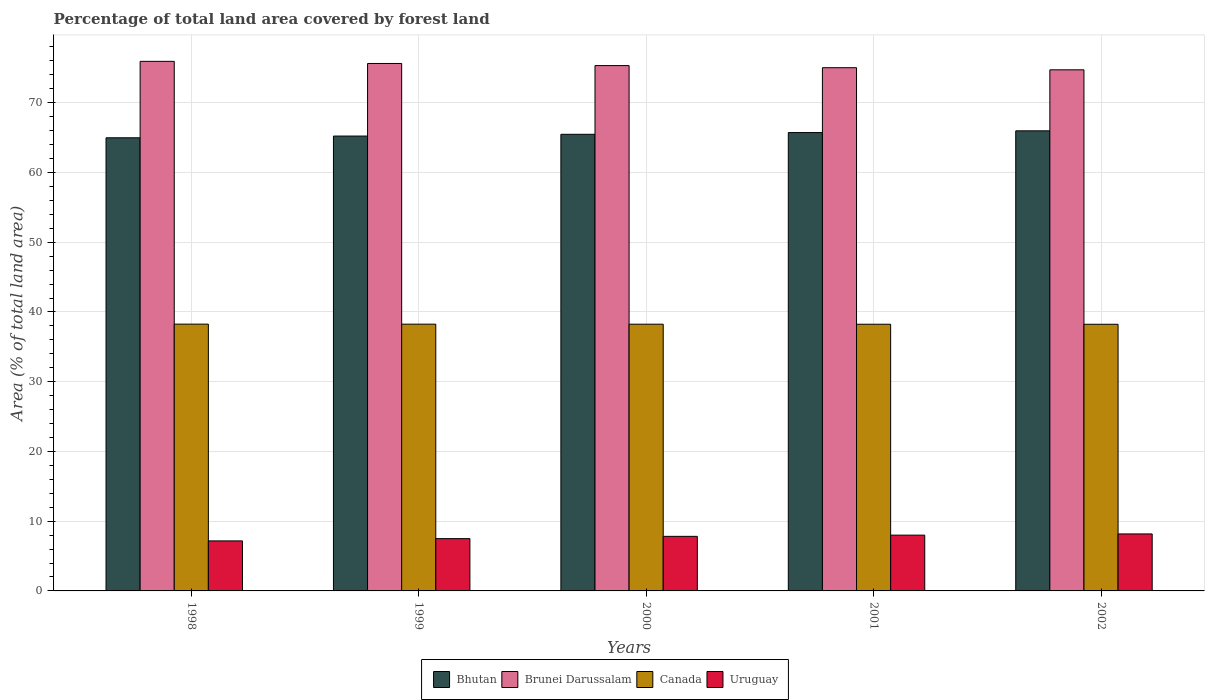How many different coloured bars are there?
Your answer should be compact. 4. How many groups of bars are there?
Offer a terse response. 5. Are the number of bars on each tick of the X-axis equal?
Ensure brevity in your answer.  Yes. How many bars are there on the 2nd tick from the left?
Your answer should be very brief. 4. How many bars are there on the 4th tick from the right?
Provide a succinct answer. 4. In how many cases, is the number of bars for a given year not equal to the number of legend labels?
Keep it short and to the point. 0. What is the percentage of forest land in Uruguay in 1999?
Provide a succinct answer. 7.5. Across all years, what is the maximum percentage of forest land in Bhutan?
Give a very brief answer. 65.98. Across all years, what is the minimum percentage of forest land in Canada?
Provide a short and direct response. 38.24. In which year was the percentage of forest land in Bhutan maximum?
Your answer should be compact. 2002. In which year was the percentage of forest land in Bhutan minimum?
Your response must be concise. 1998. What is the total percentage of forest land in Brunei Darussalam in the graph?
Provide a succinct answer. 376.66. What is the difference between the percentage of forest land in Brunei Darussalam in 1999 and that in 2002?
Keep it short and to the point. 0.91. What is the difference between the percentage of forest land in Bhutan in 2001 and the percentage of forest land in Brunei Darussalam in 1999?
Give a very brief answer. -9.91. What is the average percentage of forest land in Bhutan per year?
Offer a very short reply. 65.48. In the year 2001, what is the difference between the percentage of forest land in Bhutan and percentage of forest land in Canada?
Offer a very short reply. 27.48. In how many years, is the percentage of forest land in Bhutan greater than 50 %?
Provide a short and direct response. 5. What is the ratio of the percentage of forest land in Uruguay in 1998 to that in 2002?
Give a very brief answer. 0.88. What is the difference between the highest and the second highest percentage of forest land in Bhutan?
Your answer should be compact. 0.25. What is the difference between the highest and the lowest percentage of forest land in Brunei Darussalam?
Give a very brief answer. 1.21. Is it the case that in every year, the sum of the percentage of forest land in Canada and percentage of forest land in Uruguay is greater than the sum of percentage of forest land in Brunei Darussalam and percentage of forest land in Bhutan?
Keep it short and to the point. No. What does the 4th bar from the right in 1999 represents?
Make the answer very short. Bhutan. Is it the case that in every year, the sum of the percentage of forest land in Bhutan and percentage of forest land in Canada is greater than the percentage of forest land in Uruguay?
Your answer should be compact. Yes. Are all the bars in the graph horizontal?
Give a very brief answer. No. What is the difference between two consecutive major ticks on the Y-axis?
Keep it short and to the point. 10. Does the graph contain grids?
Your response must be concise. Yes. What is the title of the graph?
Offer a very short reply. Percentage of total land area covered by forest land. Does "Norway" appear as one of the legend labels in the graph?
Your response must be concise. No. What is the label or title of the Y-axis?
Your response must be concise. Area (% of total land area). What is the Area (% of total land area) of Bhutan in 1998?
Your answer should be compact. 64.98. What is the Area (% of total land area) of Brunei Darussalam in 1998?
Your response must be concise. 75.94. What is the Area (% of total land area) in Canada in 1998?
Offer a terse response. 38.26. What is the Area (% of total land area) in Uruguay in 1998?
Your answer should be very brief. 7.17. What is the Area (% of total land area) in Bhutan in 1999?
Offer a very short reply. 65.23. What is the Area (% of total land area) of Brunei Darussalam in 1999?
Make the answer very short. 75.64. What is the Area (% of total land area) of Canada in 1999?
Your answer should be compact. 38.25. What is the Area (% of total land area) in Uruguay in 1999?
Your answer should be compact. 7.5. What is the Area (% of total land area) of Bhutan in 2000?
Keep it short and to the point. 65.48. What is the Area (% of total land area) of Brunei Darussalam in 2000?
Keep it short and to the point. 75.33. What is the Area (% of total land area) of Canada in 2000?
Offer a very short reply. 38.25. What is the Area (% of total land area) in Uruguay in 2000?
Keep it short and to the point. 7.83. What is the Area (% of total land area) in Bhutan in 2001?
Your answer should be very brief. 65.73. What is the Area (% of total land area) in Brunei Darussalam in 2001?
Your answer should be compact. 75.03. What is the Area (% of total land area) of Canada in 2001?
Give a very brief answer. 38.24. What is the Area (% of total land area) in Uruguay in 2001?
Give a very brief answer. 8. What is the Area (% of total land area) in Bhutan in 2002?
Offer a very short reply. 65.98. What is the Area (% of total land area) of Brunei Darussalam in 2002?
Offer a very short reply. 74.72. What is the Area (% of total land area) in Canada in 2002?
Offer a very short reply. 38.24. What is the Area (% of total land area) of Uruguay in 2002?
Make the answer very short. 8.17. Across all years, what is the maximum Area (% of total land area) in Bhutan?
Your answer should be very brief. 65.98. Across all years, what is the maximum Area (% of total land area) of Brunei Darussalam?
Offer a very short reply. 75.94. Across all years, what is the maximum Area (% of total land area) of Canada?
Provide a succinct answer. 38.26. Across all years, what is the maximum Area (% of total land area) of Uruguay?
Keep it short and to the point. 8.17. Across all years, what is the minimum Area (% of total land area) of Bhutan?
Your answer should be compact. 64.98. Across all years, what is the minimum Area (% of total land area) in Brunei Darussalam?
Your answer should be compact. 74.72. Across all years, what is the minimum Area (% of total land area) of Canada?
Provide a succinct answer. 38.24. Across all years, what is the minimum Area (% of total land area) in Uruguay?
Your answer should be compact. 7.17. What is the total Area (% of total land area) of Bhutan in the graph?
Make the answer very short. 327.39. What is the total Area (% of total land area) of Brunei Darussalam in the graph?
Your answer should be very brief. 376.66. What is the total Area (% of total land area) in Canada in the graph?
Ensure brevity in your answer.  191.24. What is the total Area (% of total land area) of Uruguay in the graph?
Provide a succinct answer. 38.67. What is the difference between the Area (% of total land area) of Bhutan in 1998 and that in 1999?
Offer a very short reply. -0.25. What is the difference between the Area (% of total land area) of Brunei Darussalam in 1998 and that in 1999?
Provide a short and direct response. 0.3. What is the difference between the Area (% of total land area) in Canada in 1998 and that in 1999?
Provide a short and direct response. 0.01. What is the difference between the Area (% of total land area) in Uruguay in 1998 and that in 1999?
Provide a short and direct response. -0.33. What is the difference between the Area (% of total land area) in Bhutan in 1998 and that in 2000?
Offer a terse response. -0.5. What is the difference between the Area (% of total land area) in Brunei Darussalam in 1998 and that in 2000?
Provide a short and direct response. 0.61. What is the difference between the Area (% of total land area) in Canada in 1998 and that in 2000?
Your answer should be compact. 0.01. What is the difference between the Area (% of total land area) in Uruguay in 1998 and that in 2000?
Provide a succinct answer. -0.65. What is the difference between the Area (% of total land area) in Bhutan in 1998 and that in 2001?
Make the answer very short. -0.75. What is the difference between the Area (% of total land area) of Brunei Darussalam in 1998 and that in 2001?
Your answer should be compact. 0.91. What is the difference between the Area (% of total land area) of Canada in 1998 and that in 2001?
Offer a very short reply. 0.02. What is the difference between the Area (% of total land area) of Uruguay in 1998 and that in 2001?
Give a very brief answer. -0.83. What is the difference between the Area (% of total land area) in Bhutan in 1998 and that in 2002?
Your answer should be compact. -1. What is the difference between the Area (% of total land area) in Brunei Darussalam in 1998 and that in 2002?
Your answer should be very brief. 1.21. What is the difference between the Area (% of total land area) in Canada in 1998 and that in 2002?
Ensure brevity in your answer.  0.02. What is the difference between the Area (% of total land area) of Uruguay in 1998 and that in 2002?
Offer a terse response. -1. What is the difference between the Area (% of total land area) of Bhutan in 1999 and that in 2000?
Keep it short and to the point. -0.25. What is the difference between the Area (% of total land area) of Brunei Darussalam in 1999 and that in 2000?
Give a very brief answer. 0.3. What is the difference between the Area (% of total land area) of Canada in 1999 and that in 2000?
Your answer should be very brief. 0.01. What is the difference between the Area (% of total land area) of Uruguay in 1999 and that in 2000?
Provide a short and direct response. -0.33. What is the difference between the Area (% of total land area) in Bhutan in 1999 and that in 2001?
Offer a terse response. -0.5. What is the difference between the Area (% of total land area) of Brunei Darussalam in 1999 and that in 2001?
Provide a short and direct response. 0.61. What is the difference between the Area (% of total land area) in Canada in 1999 and that in 2001?
Provide a succinct answer. 0.01. What is the difference between the Area (% of total land area) in Uruguay in 1999 and that in 2001?
Keep it short and to the point. -0.5. What is the difference between the Area (% of total land area) in Bhutan in 1999 and that in 2002?
Your answer should be compact. -0.75. What is the difference between the Area (% of total land area) of Brunei Darussalam in 1999 and that in 2002?
Keep it short and to the point. 0.91. What is the difference between the Area (% of total land area) of Canada in 1999 and that in 2002?
Offer a very short reply. 0.02. What is the difference between the Area (% of total land area) of Uruguay in 1999 and that in 2002?
Ensure brevity in your answer.  -0.67. What is the difference between the Area (% of total land area) of Bhutan in 2000 and that in 2001?
Ensure brevity in your answer.  -0.25. What is the difference between the Area (% of total land area) in Brunei Darussalam in 2000 and that in 2001?
Offer a very short reply. 0.3. What is the difference between the Area (% of total land area) of Canada in 2000 and that in 2001?
Keep it short and to the point. 0.01. What is the difference between the Area (% of total land area) in Uruguay in 2000 and that in 2001?
Keep it short and to the point. -0.17. What is the difference between the Area (% of total land area) in Bhutan in 2000 and that in 2002?
Give a very brief answer. -0.5. What is the difference between the Area (% of total land area) of Brunei Darussalam in 2000 and that in 2002?
Keep it short and to the point. 0.61. What is the difference between the Area (% of total land area) in Canada in 2000 and that in 2002?
Offer a very short reply. 0.01. What is the difference between the Area (% of total land area) in Uruguay in 2000 and that in 2002?
Make the answer very short. -0.35. What is the difference between the Area (% of total land area) of Bhutan in 2001 and that in 2002?
Provide a short and direct response. -0.25. What is the difference between the Area (% of total land area) of Brunei Darussalam in 2001 and that in 2002?
Your answer should be compact. 0.3. What is the difference between the Area (% of total land area) in Canada in 2001 and that in 2002?
Your response must be concise. 0.01. What is the difference between the Area (% of total land area) in Uruguay in 2001 and that in 2002?
Provide a succinct answer. -0.17. What is the difference between the Area (% of total land area) of Bhutan in 1998 and the Area (% of total land area) of Brunei Darussalam in 1999?
Your answer should be compact. -10.66. What is the difference between the Area (% of total land area) of Bhutan in 1998 and the Area (% of total land area) of Canada in 1999?
Give a very brief answer. 26.73. What is the difference between the Area (% of total land area) of Bhutan in 1998 and the Area (% of total land area) of Uruguay in 1999?
Your answer should be very brief. 57.48. What is the difference between the Area (% of total land area) in Brunei Darussalam in 1998 and the Area (% of total land area) in Canada in 1999?
Provide a short and direct response. 37.69. What is the difference between the Area (% of total land area) in Brunei Darussalam in 1998 and the Area (% of total land area) in Uruguay in 1999?
Provide a succinct answer. 68.44. What is the difference between the Area (% of total land area) in Canada in 1998 and the Area (% of total land area) in Uruguay in 1999?
Provide a short and direct response. 30.76. What is the difference between the Area (% of total land area) of Bhutan in 1998 and the Area (% of total land area) of Brunei Darussalam in 2000?
Offer a very short reply. -10.35. What is the difference between the Area (% of total land area) of Bhutan in 1998 and the Area (% of total land area) of Canada in 2000?
Provide a short and direct response. 26.73. What is the difference between the Area (% of total land area) in Bhutan in 1998 and the Area (% of total land area) in Uruguay in 2000?
Keep it short and to the point. 57.15. What is the difference between the Area (% of total land area) of Brunei Darussalam in 1998 and the Area (% of total land area) of Canada in 2000?
Your response must be concise. 37.69. What is the difference between the Area (% of total land area) of Brunei Darussalam in 1998 and the Area (% of total land area) of Uruguay in 2000?
Offer a terse response. 68.11. What is the difference between the Area (% of total land area) in Canada in 1998 and the Area (% of total land area) in Uruguay in 2000?
Offer a very short reply. 30.43. What is the difference between the Area (% of total land area) of Bhutan in 1998 and the Area (% of total land area) of Brunei Darussalam in 2001?
Make the answer very short. -10.05. What is the difference between the Area (% of total land area) of Bhutan in 1998 and the Area (% of total land area) of Canada in 2001?
Your response must be concise. 26.74. What is the difference between the Area (% of total land area) of Bhutan in 1998 and the Area (% of total land area) of Uruguay in 2001?
Provide a succinct answer. 56.98. What is the difference between the Area (% of total land area) in Brunei Darussalam in 1998 and the Area (% of total land area) in Canada in 2001?
Your answer should be compact. 37.7. What is the difference between the Area (% of total land area) of Brunei Darussalam in 1998 and the Area (% of total land area) of Uruguay in 2001?
Ensure brevity in your answer.  67.94. What is the difference between the Area (% of total land area) of Canada in 1998 and the Area (% of total land area) of Uruguay in 2001?
Make the answer very short. 30.26. What is the difference between the Area (% of total land area) of Bhutan in 1998 and the Area (% of total land area) of Brunei Darussalam in 2002?
Make the answer very short. -9.75. What is the difference between the Area (% of total land area) in Bhutan in 1998 and the Area (% of total land area) in Canada in 2002?
Ensure brevity in your answer.  26.74. What is the difference between the Area (% of total land area) of Bhutan in 1998 and the Area (% of total land area) of Uruguay in 2002?
Give a very brief answer. 56.8. What is the difference between the Area (% of total land area) of Brunei Darussalam in 1998 and the Area (% of total land area) of Canada in 2002?
Make the answer very short. 37.7. What is the difference between the Area (% of total land area) of Brunei Darussalam in 1998 and the Area (% of total land area) of Uruguay in 2002?
Your answer should be compact. 67.77. What is the difference between the Area (% of total land area) in Canada in 1998 and the Area (% of total land area) in Uruguay in 2002?
Ensure brevity in your answer.  30.08. What is the difference between the Area (% of total land area) in Bhutan in 1999 and the Area (% of total land area) in Brunei Darussalam in 2000?
Keep it short and to the point. -10.1. What is the difference between the Area (% of total land area) of Bhutan in 1999 and the Area (% of total land area) of Canada in 2000?
Make the answer very short. 26.98. What is the difference between the Area (% of total land area) of Bhutan in 1999 and the Area (% of total land area) of Uruguay in 2000?
Offer a very short reply. 57.4. What is the difference between the Area (% of total land area) of Brunei Darussalam in 1999 and the Area (% of total land area) of Canada in 2000?
Keep it short and to the point. 37.39. What is the difference between the Area (% of total land area) of Brunei Darussalam in 1999 and the Area (% of total land area) of Uruguay in 2000?
Offer a terse response. 67.81. What is the difference between the Area (% of total land area) in Canada in 1999 and the Area (% of total land area) in Uruguay in 2000?
Provide a succinct answer. 30.43. What is the difference between the Area (% of total land area) of Bhutan in 1999 and the Area (% of total land area) of Brunei Darussalam in 2001?
Your answer should be compact. -9.8. What is the difference between the Area (% of total land area) of Bhutan in 1999 and the Area (% of total land area) of Canada in 2001?
Your response must be concise. 26.99. What is the difference between the Area (% of total land area) of Bhutan in 1999 and the Area (% of total land area) of Uruguay in 2001?
Offer a very short reply. 57.23. What is the difference between the Area (% of total land area) of Brunei Darussalam in 1999 and the Area (% of total land area) of Canada in 2001?
Make the answer very short. 37.39. What is the difference between the Area (% of total land area) in Brunei Darussalam in 1999 and the Area (% of total land area) in Uruguay in 2001?
Ensure brevity in your answer.  67.64. What is the difference between the Area (% of total land area) of Canada in 1999 and the Area (% of total land area) of Uruguay in 2001?
Ensure brevity in your answer.  30.25. What is the difference between the Area (% of total land area) of Bhutan in 1999 and the Area (% of total land area) of Brunei Darussalam in 2002?
Offer a terse response. -9.5. What is the difference between the Area (% of total land area) in Bhutan in 1999 and the Area (% of total land area) in Canada in 2002?
Keep it short and to the point. 26.99. What is the difference between the Area (% of total land area) in Bhutan in 1999 and the Area (% of total land area) in Uruguay in 2002?
Make the answer very short. 57.05. What is the difference between the Area (% of total land area) in Brunei Darussalam in 1999 and the Area (% of total land area) in Canada in 2002?
Provide a short and direct response. 37.4. What is the difference between the Area (% of total land area) in Brunei Darussalam in 1999 and the Area (% of total land area) in Uruguay in 2002?
Ensure brevity in your answer.  67.46. What is the difference between the Area (% of total land area) in Canada in 1999 and the Area (% of total land area) in Uruguay in 2002?
Offer a very short reply. 30.08. What is the difference between the Area (% of total land area) of Bhutan in 2000 and the Area (% of total land area) of Brunei Darussalam in 2001?
Provide a succinct answer. -9.55. What is the difference between the Area (% of total land area) in Bhutan in 2000 and the Area (% of total land area) in Canada in 2001?
Provide a short and direct response. 27.24. What is the difference between the Area (% of total land area) in Bhutan in 2000 and the Area (% of total land area) in Uruguay in 2001?
Provide a succinct answer. 57.48. What is the difference between the Area (% of total land area) in Brunei Darussalam in 2000 and the Area (% of total land area) in Canada in 2001?
Provide a succinct answer. 37.09. What is the difference between the Area (% of total land area) of Brunei Darussalam in 2000 and the Area (% of total land area) of Uruguay in 2001?
Give a very brief answer. 67.33. What is the difference between the Area (% of total land area) in Canada in 2000 and the Area (% of total land area) in Uruguay in 2001?
Your answer should be very brief. 30.25. What is the difference between the Area (% of total land area) of Bhutan in 2000 and the Area (% of total land area) of Brunei Darussalam in 2002?
Provide a succinct answer. -9.25. What is the difference between the Area (% of total land area) of Bhutan in 2000 and the Area (% of total land area) of Canada in 2002?
Keep it short and to the point. 27.24. What is the difference between the Area (% of total land area) in Bhutan in 2000 and the Area (% of total land area) in Uruguay in 2002?
Your response must be concise. 57.3. What is the difference between the Area (% of total land area) in Brunei Darussalam in 2000 and the Area (% of total land area) in Canada in 2002?
Ensure brevity in your answer.  37.09. What is the difference between the Area (% of total land area) of Brunei Darussalam in 2000 and the Area (% of total land area) of Uruguay in 2002?
Give a very brief answer. 67.16. What is the difference between the Area (% of total land area) in Canada in 2000 and the Area (% of total land area) in Uruguay in 2002?
Make the answer very short. 30.07. What is the difference between the Area (% of total land area) of Bhutan in 2001 and the Area (% of total land area) of Brunei Darussalam in 2002?
Your response must be concise. -9. What is the difference between the Area (% of total land area) in Bhutan in 2001 and the Area (% of total land area) in Canada in 2002?
Offer a very short reply. 27.49. What is the difference between the Area (% of total land area) of Bhutan in 2001 and the Area (% of total land area) of Uruguay in 2002?
Give a very brief answer. 57.55. What is the difference between the Area (% of total land area) in Brunei Darussalam in 2001 and the Area (% of total land area) in Canada in 2002?
Keep it short and to the point. 36.79. What is the difference between the Area (% of total land area) of Brunei Darussalam in 2001 and the Area (% of total land area) of Uruguay in 2002?
Give a very brief answer. 66.85. What is the difference between the Area (% of total land area) in Canada in 2001 and the Area (% of total land area) in Uruguay in 2002?
Provide a short and direct response. 30.07. What is the average Area (% of total land area) of Bhutan per year?
Provide a succinct answer. 65.48. What is the average Area (% of total land area) in Brunei Darussalam per year?
Offer a terse response. 75.33. What is the average Area (% of total land area) of Canada per year?
Make the answer very short. 38.25. What is the average Area (% of total land area) of Uruguay per year?
Keep it short and to the point. 7.73. In the year 1998, what is the difference between the Area (% of total land area) in Bhutan and Area (% of total land area) in Brunei Darussalam?
Your answer should be compact. -10.96. In the year 1998, what is the difference between the Area (% of total land area) in Bhutan and Area (% of total land area) in Canada?
Provide a succinct answer. 26.72. In the year 1998, what is the difference between the Area (% of total land area) in Bhutan and Area (% of total land area) in Uruguay?
Your response must be concise. 57.81. In the year 1998, what is the difference between the Area (% of total land area) of Brunei Darussalam and Area (% of total land area) of Canada?
Offer a terse response. 37.68. In the year 1998, what is the difference between the Area (% of total land area) of Brunei Darussalam and Area (% of total land area) of Uruguay?
Offer a very short reply. 68.77. In the year 1998, what is the difference between the Area (% of total land area) of Canada and Area (% of total land area) of Uruguay?
Your answer should be compact. 31.09. In the year 1999, what is the difference between the Area (% of total land area) of Bhutan and Area (% of total land area) of Brunei Darussalam?
Keep it short and to the point. -10.41. In the year 1999, what is the difference between the Area (% of total land area) in Bhutan and Area (% of total land area) in Canada?
Offer a terse response. 26.98. In the year 1999, what is the difference between the Area (% of total land area) in Bhutan and Area (% of total land area) in Uruguay?
Offer a terse response. 57.73. In the year 1999, what is the difference between the Area (% of total land area) of Brunei Darussalam and Area (% of total land area) of Canada?
Your answer should be very brief. 37.38. In the year 1999, what is the difference between the Area (% of total land area) in Brunei Darussalam and Area (% of total land area) in Uruguay?
Your answer should be compact. 68.14. In the year 1999, what is the difference between the Area (% of total land area) in Canada and Area (% of total land area) in Uruguay?
Keep it short and to the point. 30.75. In the year 2000, what is the difference between the Area (% of total land area) in Bhutan and Area (% of total land area) in Brunei Darussalam?
Offer a terse response. -9.85. In the year 2000, what is the difference between the Area (% of total land area) in Bhutan and Area (% of total land area) in Canada?
Make the answer very short. 27.23. In the year 2000, what is the difference between the Area (% of total land area) in Bhutan and Area (% of total land area) in Uruguay?
Your answer should be compact. 57.65. In the year 2000, what is the difference between the Area (% of total land area) of Brunei Darussalam and Area (% of total land area) of Canada?
Your answer should be very brief. 37.08. In the year 2000, what is the difference between the Area (% of total land area) of Brunei Darussalam and Area (% of total land area) of Uruguay?
Provide a short and direct response. 67.51. In the year 2000, what is the difference between the Area (% of total land area) in Canada and Area (% of total land area) in Uruguay?
Keep it short and to the point. 30.42. In the year 2001, what is the difference between the Area (% of total land area) in Bhutan and Area (% of total land area) in Brunei Darussalam?
Your answer should be compact. -9.3. In the year 2001, what is the difference between the Area (% of total land area) of Bhutan and Area (% of total land area) of Canada?
Give a very brief answer. 27.48. In the year 2001, what is the difference between the Area (% of total land area) in Bhutan and Area (% of total land area) in Uruguay?
Your answer should be very brief. 57.73. In the year 2001, what is the difference between the Area (% of total land area) in Brunei Darussalam and Area (% of total land area) in Canada?
Provide a short and direct response. 36.79. In the year 2001, what is the difference between the Area (% of total land area) in Brunei Darussalam and Area (% of total land area) in Uruguay?
Provide a short and direct response. 67.03. In the year 2001, what is the difference between the Area (% of total land area) of Canada and Area (% of total land area) of Uruguay?
Your answer should be very brief. 30.24. In the year 2002, what is the difference between the Area (% of total land area) in Bhutan and Area (% of total land area) in Brunei Darussalam?
Offer a very short reply. -8.75. In the year 2002, what is the difference between the Area (% of total land area) of Bhutan and Area (% of total land area) of Canada?
Offer a very short reply. 27.74. In the year 2002, what is the difference between the Area (% of total land area) in Bhutan and Area (% of total land area) in Uruguay?
Keep it short and to the point. 57.8. In the year 2002, what is the difference between the Area (% of total land area) in Brunei Darussalam and Area (% of total land area) in Canada?
Offer a very short reply. 36.49. In the year 2002, what is the difference between the Area (% of total land area) of Brunei Darussalam and Area (% of total land area) of Uruguay?
Provide a short and direct response. 66.55. In the year 2002, what is the difference between the Area (% of total land area) of Canada and Area (% of total land area) of Uruguay?
Ensure brevity in your answer.  30.06. What is the ratio of the Area (% of total land area) in Uruguay in 1998 to that in 1999?
Your answer should be compact. 0.96. What is the ratio of the Area (% of total land area) of Canada in 1998 to that in 2000?
Keep it short and to the point. 1. What is the ratio of the Area (% of total land area) in Uruguay in 1998 to that in 2000?
Provide a succinct answer. 0.92. What is the ratio of the Area (% of total land area) of Bhutan in 1998 to that in 2001?
Your answer should be compact. 0.99. What is the ratio of the Area (% of total land area) of Brunei Darussalam in 1998 to that in 2001?
Offer a very short reply. 1.01. What is the ratio of the Area (% of total land area) in Canada in 1998 to that in 2001?
Offer a very short reply. 1. What is the ratio of the Area (% of total land area) of Uruguay in 1998 to that in 2001?
Your answer should be compact. 0.9. What is the ratio of the Area (% of total land area) of Bhutan in 1998 to that in 2002?
Your answer should be compact. 0.98. What is the ratio of the Area (% of total land area) of Brunei Darussalam in 1998 to that in 2002?
Ensure brevity in your answer.  1.02. What is the ratio of the Area (% of total land area) in Canada in 1998 to that in 2002?
Ensure brevity in your answer.  1. What is the ratio of the Area (% of total land area) of Uruguay in 1998 to that in 2002?
Provide a short and direct response. 0.88. What is the ratio of the Area (% of total land area) in Canada in 1999 to that in 2000?
Give a very brief answer. 1. What is the ratio of the Area (% of total land area) of Uruguay in 1999 to that in 2000?
Provide a succinct answer. 0.96. What is the ratio of the Area (% of total land area) in Brunei Darussalam in 1999 to that in 2001?
Provide a short and direct response. 1.01. What is the ratio of the Area (% of total land area) in Uruguay in 1999 to that in 2001?
Make the answer very short. 0.94. What is the ratio of the Area (% of total land area) of Bhutan in 1999 to that in 2002?
Ensure brevity in your answer.  0.99. What is the ratio of the Area (% of total land area) of Brunei Darussalam in 1999 to that in 2002?
Provide a succinct answer. 1.01. What is the ratio of the Area (% of total land area) in Canada in 1999 to that in 2002?
Offer a very short reply. 1. What is the ratio of the Area (% of total land area) in Uruguay in 1999 to that in 2002?
Your answer should be very brief. 0.92. What is the ratio of the Area (% of total land area) in Bhutan in 2000 to that in 2001?
Keep it short and to the point. 1. What is the ratio of the Area (% of total land area) of Brunei Darussalam in 2000 to that in 2001?
Give a very brief answer. 1. What is the ratio of the Area (% of total land area) of Canada in 2000 to that in 2001?
Ensure brevity in your answer.  1. What is the ratio of the Area (% of total land area) of Uruguay in 2000 to that in 2001?
Offer a very short reply. 0.98. What is the ratio of the Area (% of total land area) of Bhutan in 2000 to that in 2002?
Make the answer very short. 0.99. What is the ratio of the Area (% of total land area) in Uruguay in 2000 to that in 2002?
Your answer should be compact. 0.96. What is the ratio of the Area (% of total land area) of Uruguay in 2001 to that in 2002?
Give a very brief answer. 0.98. What is the difference between the highest and the second highest Area (% of total land area) of Bhutan?
Provide a short and direct response. 0.25. What is the difference between the highest and the second highest Area (% of total land area) of Brunei Darussalam?
Your answer should be very brief. 0.3. What is the difference between the highest and the second highest Area (% of total land area) of Canada?
Your response must be concise. 0.01. What is the difference between the highest and the second highest Area (% of total land area) of Uruguay?
Your answer should be compact. 0.17. What is the difference between the highest and the lowest Area (% of total land area) in Bhutan?
Your answer should be very brief. 1. What is the difference between the highest and the lowest Area (% of total land area) of Brunei Darussalam?
Give a very brief answer. 1.21. What is the difference between the highest and the lowest Area (% of total land area) of Canada?
Your response must be concise. 0.02. 